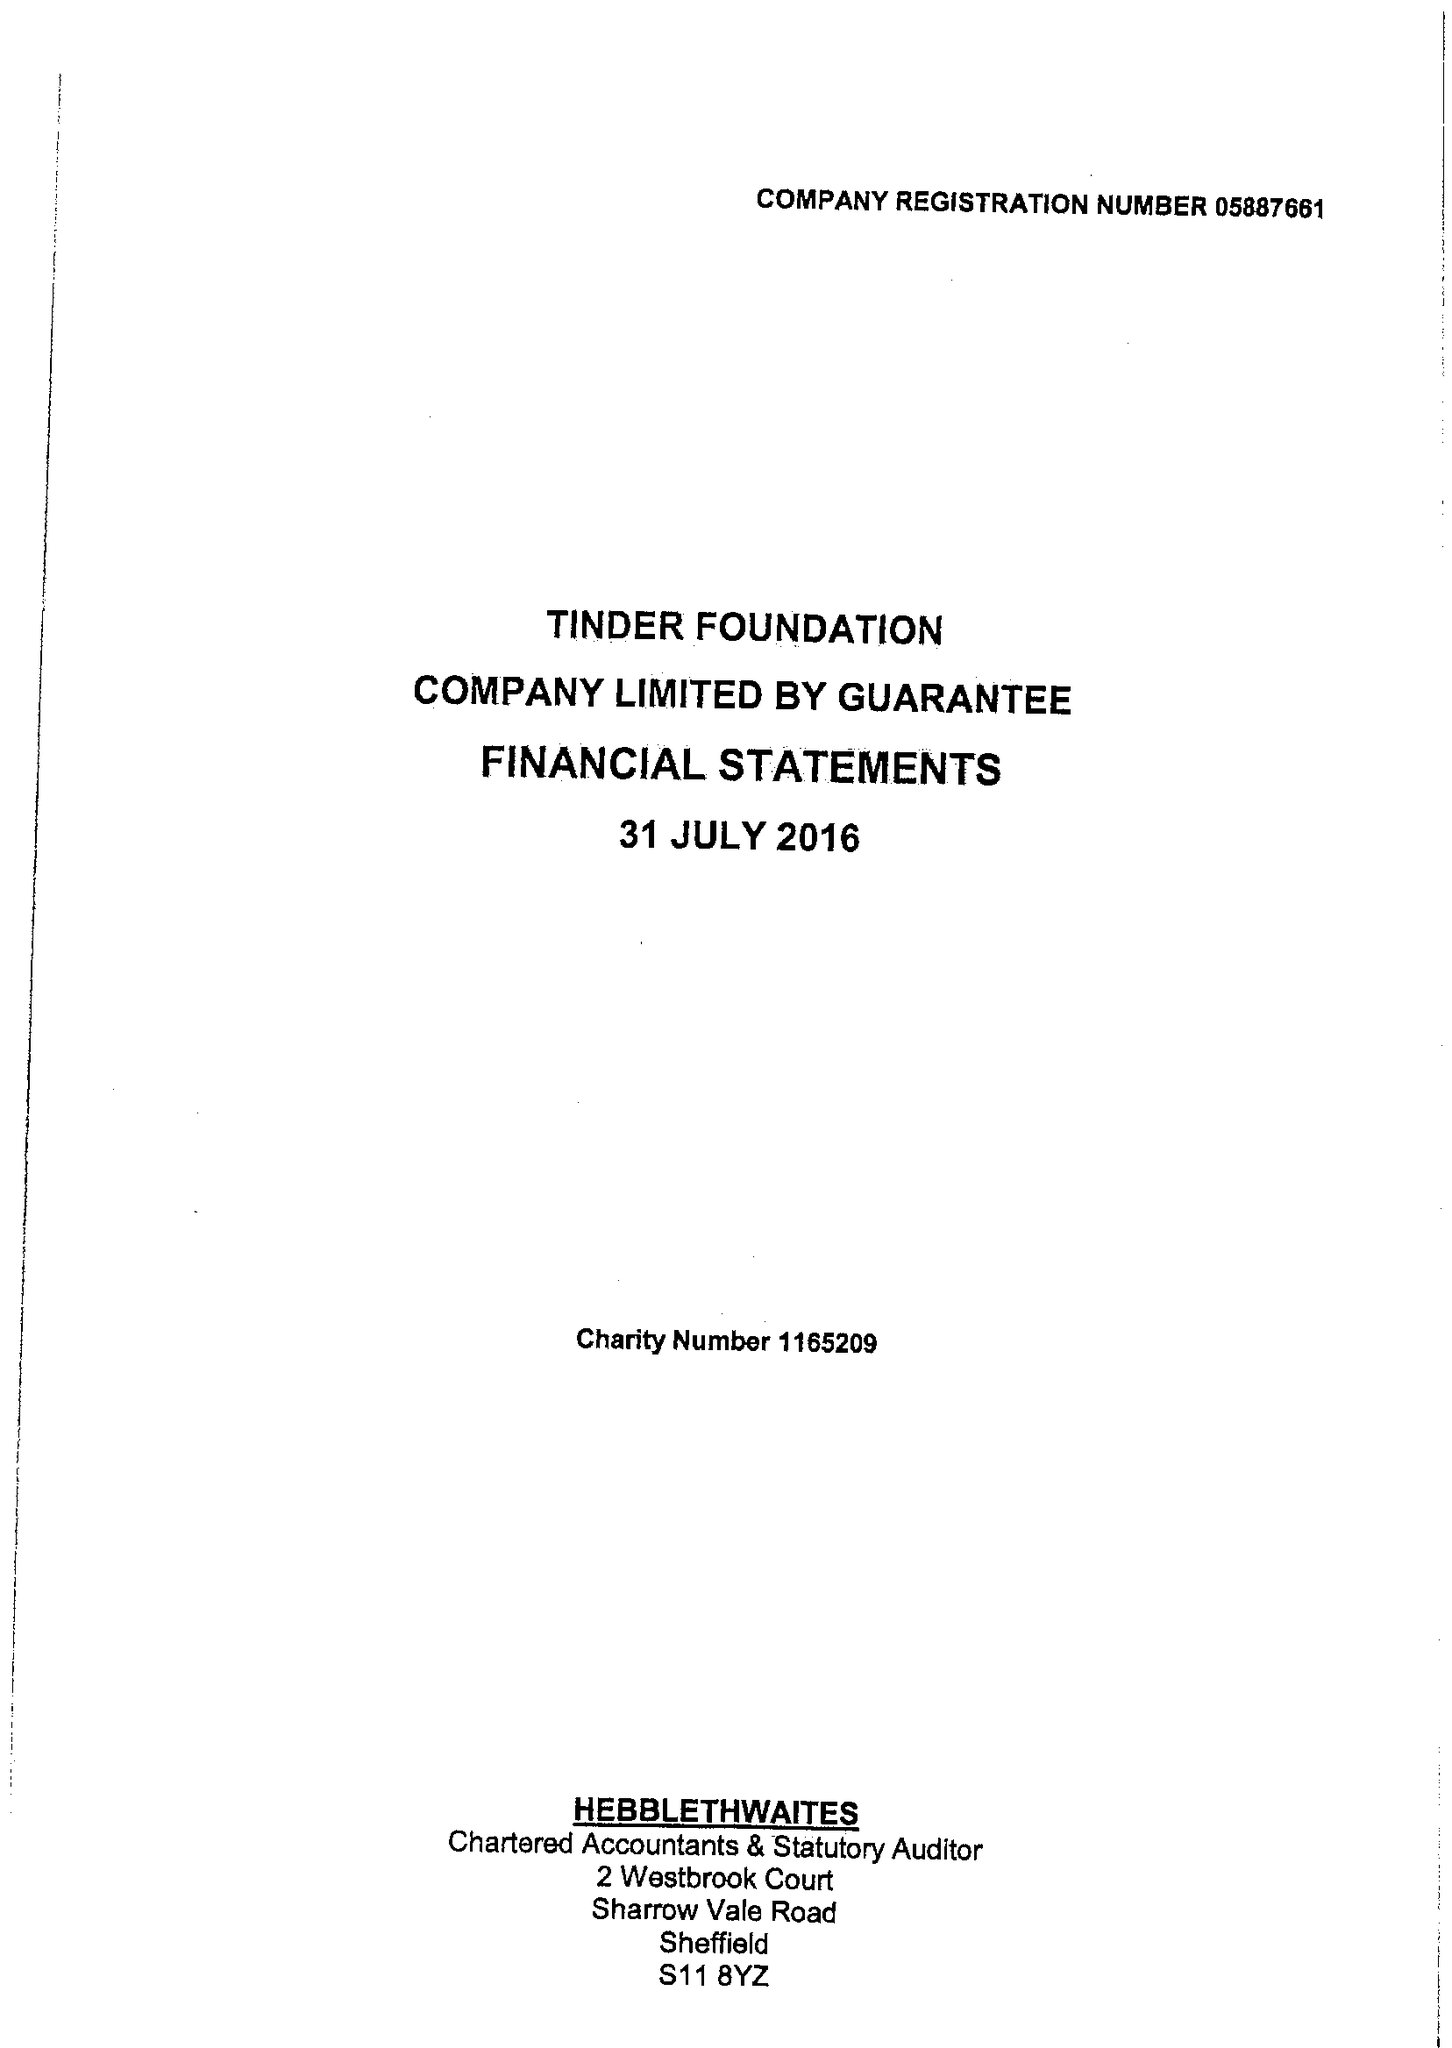What is the value for the address__street_line?
Answer the question using a single word or phrase. 1 EAST PARADE 